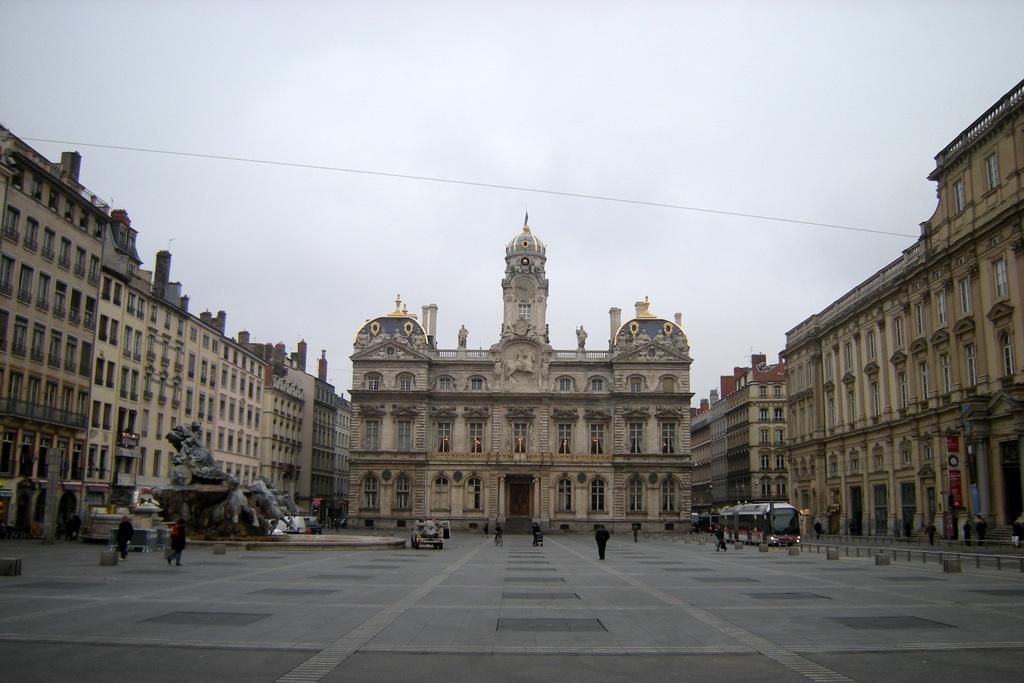Describe this image in one or two sentences. In this picture we can see few buildings and people, in front of the buildings we can find statues, vehicles and hoardings. 